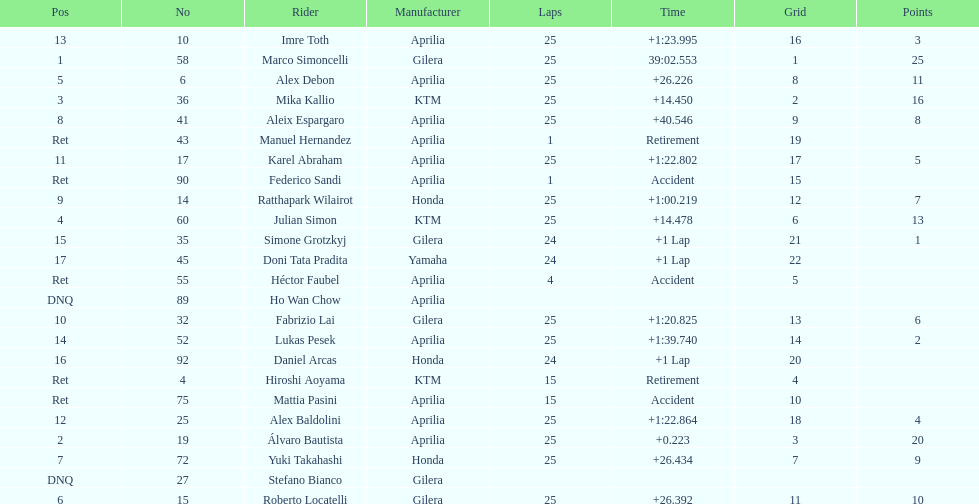What is the total number of rider? 24. 